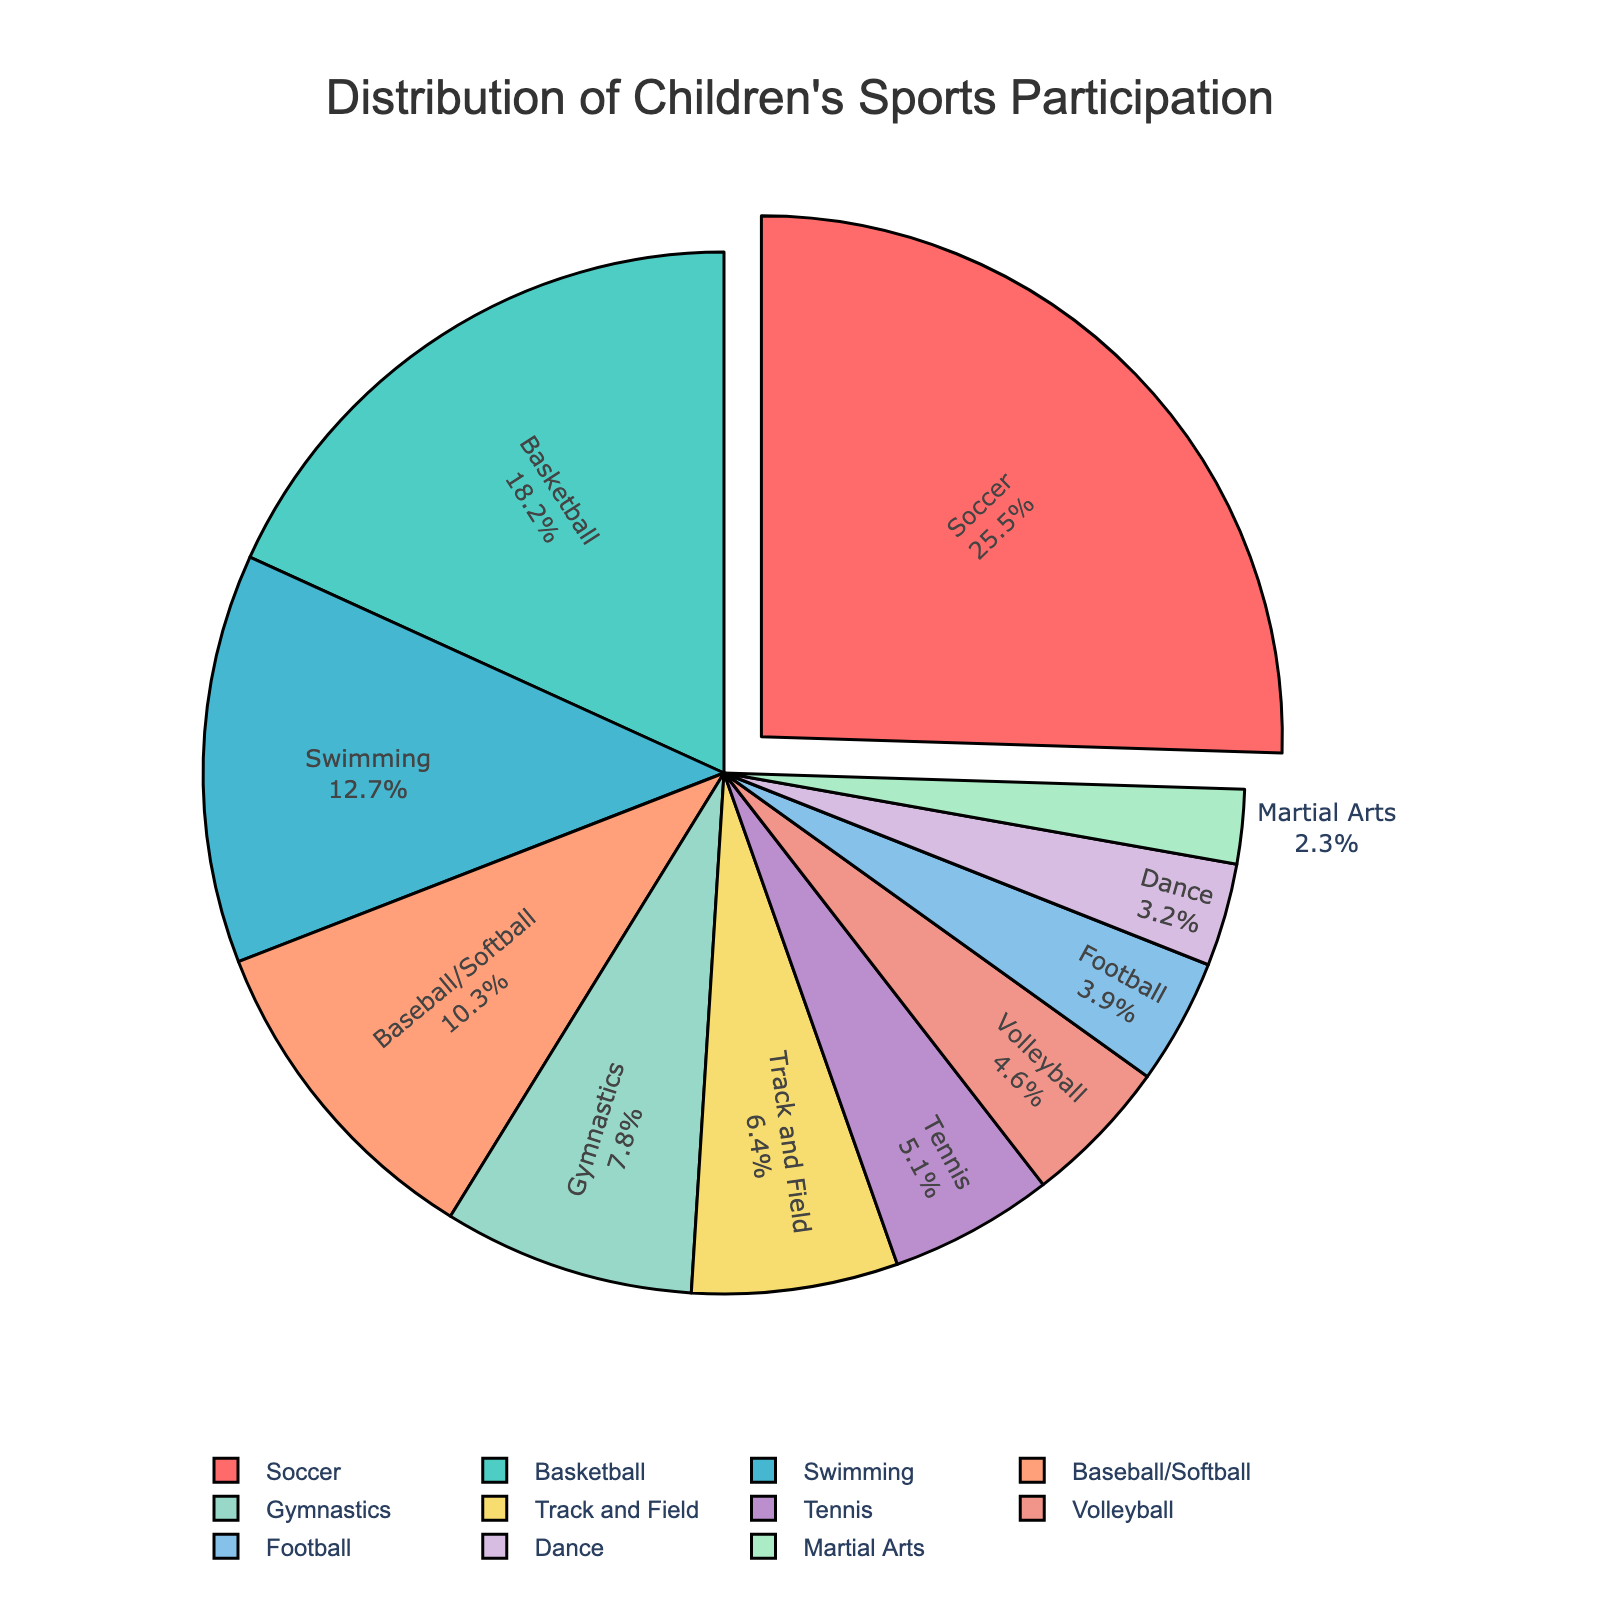what activity has the highest participation rate? The pie chart shows the largest segment pulled away from the center, indicating the activity with the highest percentage. Inspecting the chart, the largest segment represents Soccer at 25.5%.
Answer: Soccer what is the combined percentage of children participating in Swimming and Gymnastics? According to the pie chart, Swimming has a participation rate of 12.7% and Gymnastics has 7.8%. Adding these, 12.7 + 7.8 = 20.5%.
Answer: 20.5% How much greater is the participation percentage of Soccer compared to Football? The pie chart indicates Soccer has a percentage of 25.5% and Football has 3.9%. Subtracting, 25.5 - 3.9 = 21.6.
Answer: 21.6% Which activities have a participation rate below 5%? From the pie chart, the segments smaller than 5% are Tennis (5.1%), Volleyball (4.6%), Football (3.9%), Dance (3.2%), and Martial Arts (2.3%). Out of these, Volleyball, Football, Dance, and Martial Arts have below 5%.
Answer: Volleyball, Football, Dance, Martial Arts What is the sum of participation percentages for Baseball/Softball, Track and Field, and Tennis? The pie chart shows Baseball/Softball at 10.3%, Track and Field at 6.4%, and Tennis at 5.1%. Adding these values: 10.3 + 6.4 + 5.1 = 21.8%.
Answer: 21.8% Is the participation rate in Basketball greater than in Swimming and Gymnastics combined? Basketball has a participation rate of 18.2%. The combined rate for Swimming (12.7%) and Gymnastics (7.8%) is 12.7 + 7.8 = 20.5%. Comparing these, 18.2 is less than 20.5.
Answer: No What percentage of children participate in activities other than Soccer, Basketball, and Swimming? Adding up the rates for Soccer (25.5%), Basketball (18.2%), and Swimming (12.7%): 25.5 + 18.2 + 12.7 = 56.4%. Subtracting this from 100%, 100 - 56.4 = 43.6%.
Answer: 43.6% Which activity has the smallest participation rate, and what is it? By observing the smallest segment in the pie chart, it represents Martial Arts at 2.3%.
Answer: Martial Arts, 2.3% 